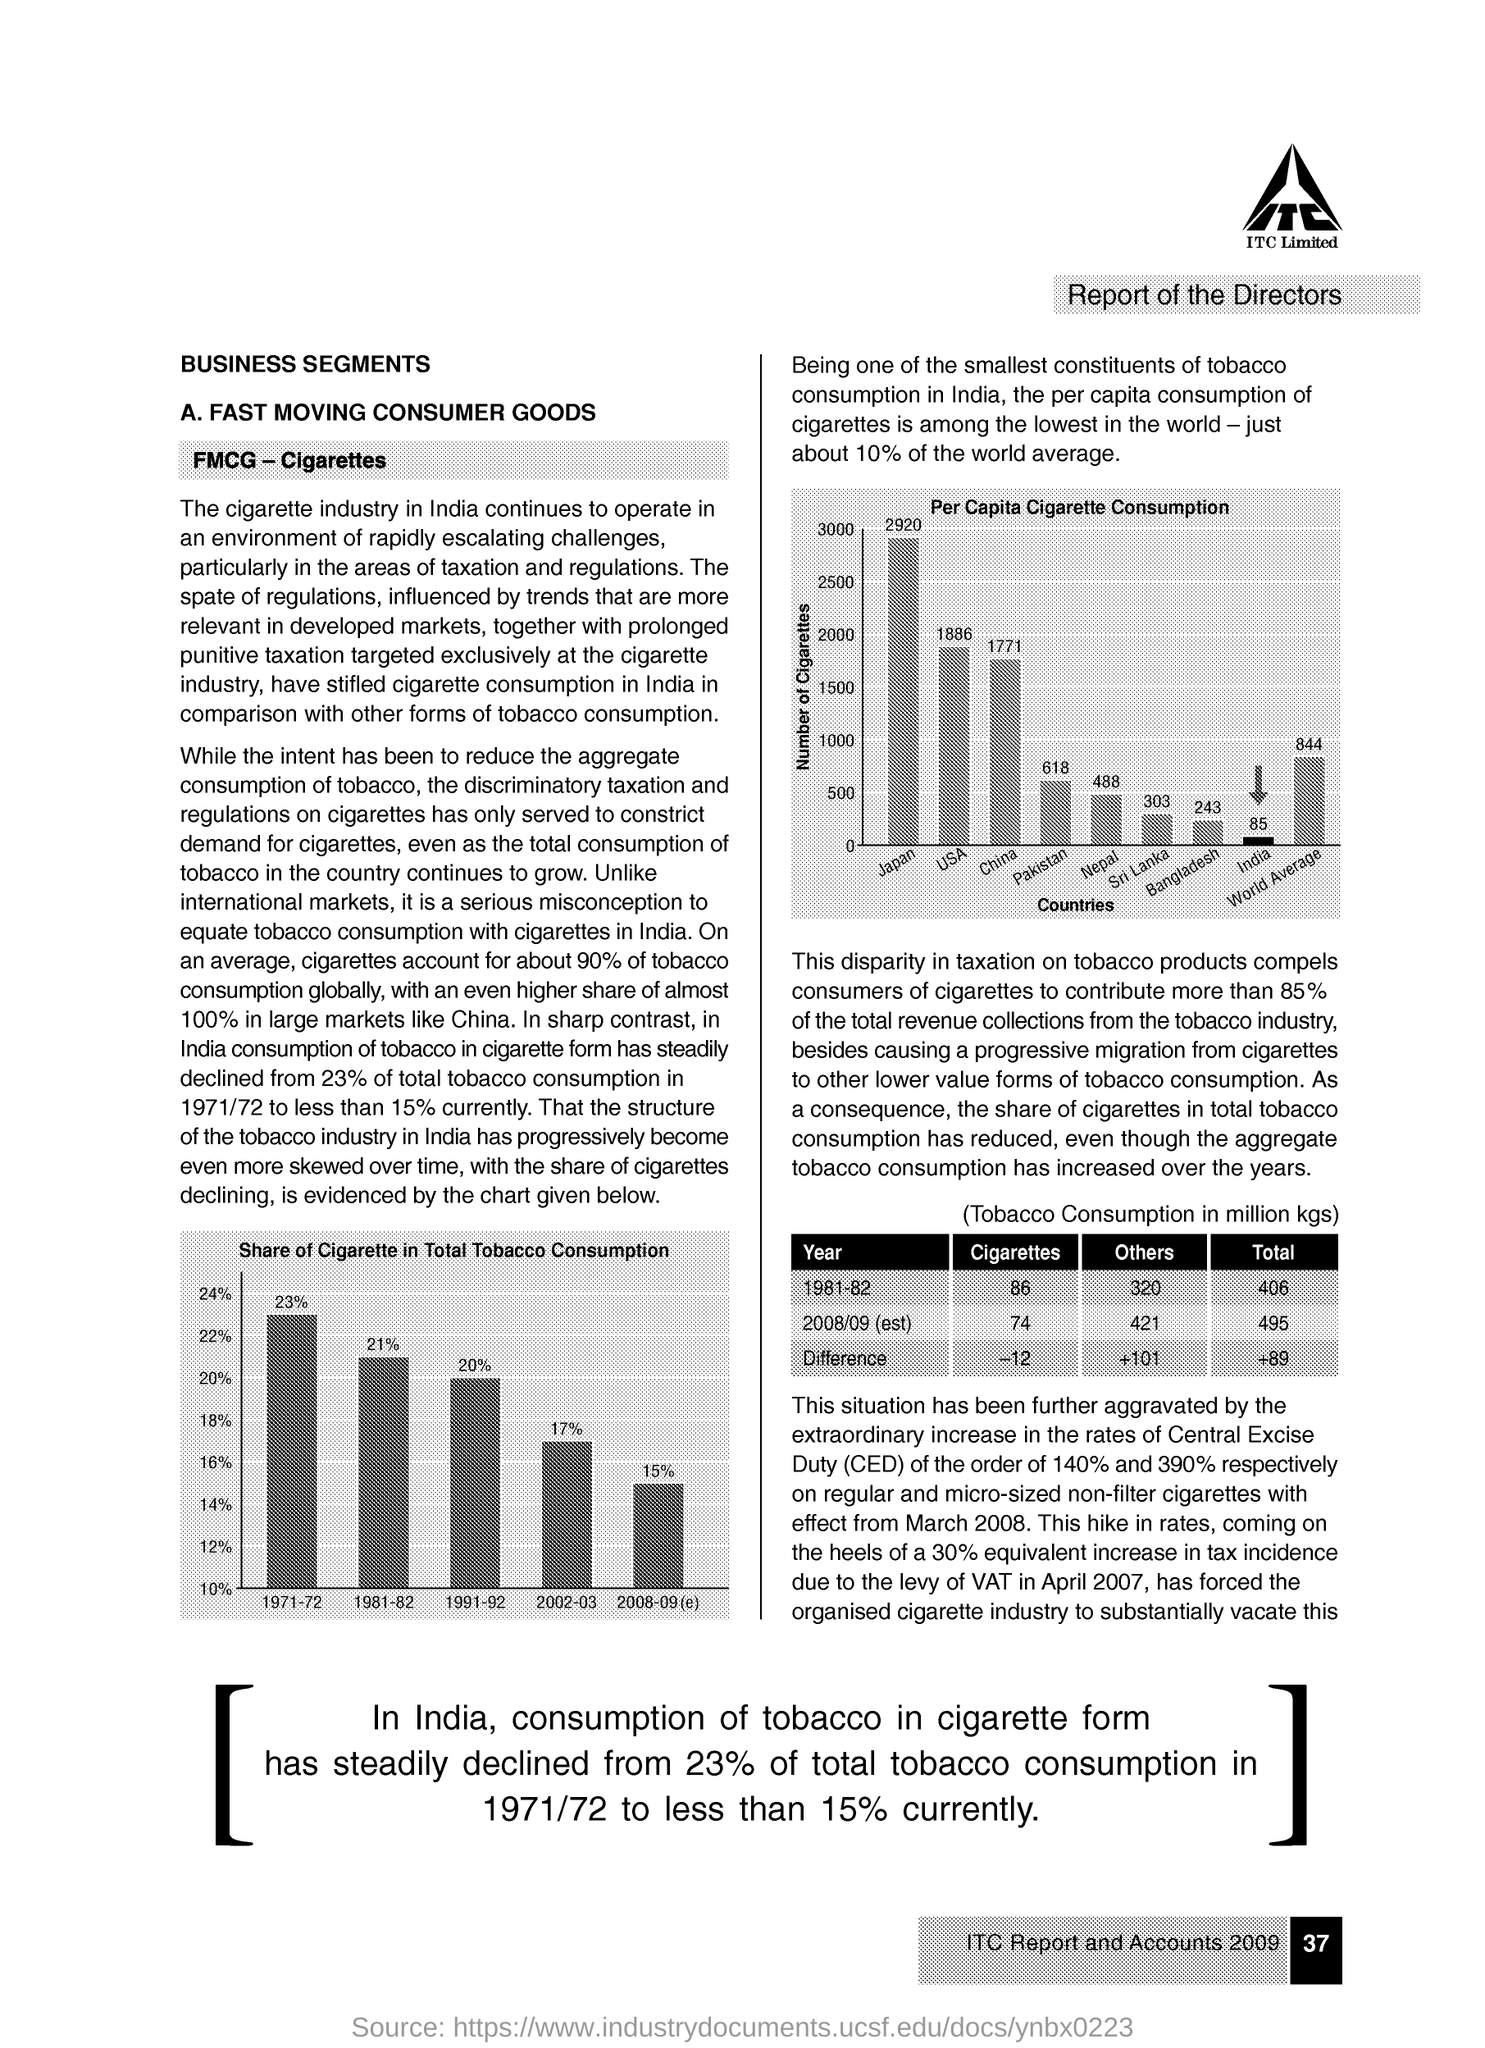Specify some key components in this picture. Per capita cigarette consumption in the country of Pakistan is 618 cigarettes per year, according to recent estimates. Per capita cigarette consumption in China is approximately 1771 cigarettes per year. 